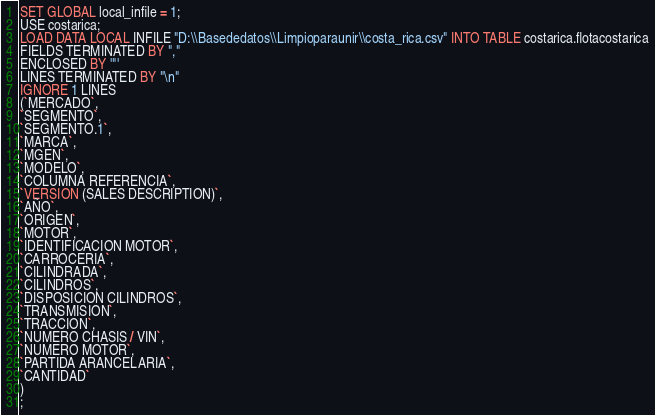Convert code to text. <code><loc_0><loc_0><loc_500><loc_500><_SQL_>SET GLOBAL local_infile = 1;
USE costarica;
LOAD DATA LOCAL INFILE "D:\\Basededatos\\Limpioparaunir\\costa_rica.csv" INTO TABLE costarica.flotacostarica
FIELDS TERMINATED BY ","
ENCLOSED BY '"'
LINES TERMINATED BY "\n"
IGNORE 1 LINES
(`MERCADO`,
`SEGMENTO`,
`SEGMENTO.1`,
`MARCA`,
`MGEN`,
`MODELO`,
`COLUMNA REFERENCIA`,
`VERSION (SALES DESCRIPTION)`,
`AÑO`,
`ORIGEN`,
`MOTOR`,
`IDENTIFICACION MOTOR`,
`CARROCERIA`,
`CILINDRADA`,
`CILINDROS`,
`DISPOSICION CILINDROS`,
`TRANSMISION`,
`TRACCION`,
`NUMERO CHASIS / VIN`,
`NUMERO MOTOR`,
`PARTIDA ARANCELARIA`,
`CANTIDAD`
)
;</code> 